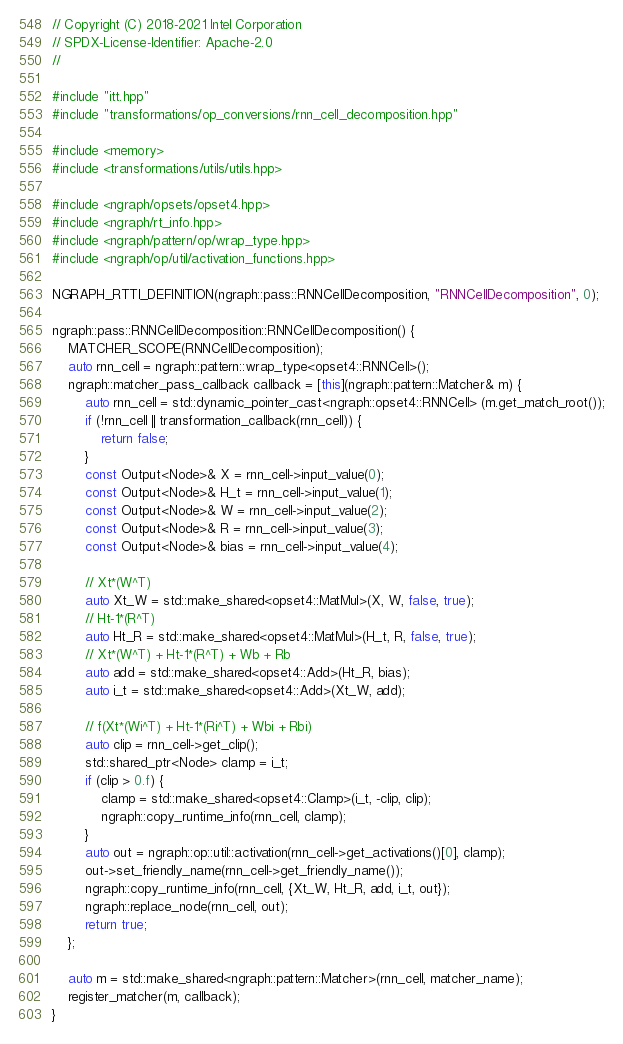<code> <loc_0><loc_0><loc_500><loc_500><_C++_>// Copyright (C) 2018-2021 Intel Corporation
// SPDX-License-Identifier: Apache-2.0
//

#include "itt.hpp"
#include "transformations/op_conversions/rnn_cell_decomposition.hpp"

#include <memory>
#include <transformations/utils/utils.hpp>

#include <ngraph/opsets/opset4.hpp>
#include <ngraph/rt_info.hpp>
#include <ngraph/pattern/op/wrap_type.hpp>
#include <ngraph/op/util/activation_functions.hpp>

NGRAPH_RTTI_DEFINITION(ngraph::pass::RNNCellDecomposition, "RNNCellDecomposition", 0);

ngraph::pass::RNNCellDecomposition::RNNCellDecomposition() {
    MATCHER_SCOPE(RNNCellDecomposition);
    auto rnn_cell = ngraph::pattern::wrap_type<opset4::RNNCell>();
    ngraph::matcher_pass_callback callback = [this](ngraph::pattern::Matcher& m) {
        auto rnn_cell = std::dynamic_pointer_cast<ngraph::opset4::RNNCell> (m.get_match_root());
        if (!rnn_cell || transformation_callback(rnn_cell)) {
            return false;
        }
        const Output<Node>& X = rnn_cell->input_value(0);
        const Output<Node>& H_t = rnn_cell->input_value(1);
        const Output<Node>& W = rnn_cell->input_value(2);
        const Output<Node>& R = rnn_cell->input_value(3);
        const Output<Node>& bias = rnn_cell->input_value(4);

        // Xt*(W^T)
        auto Xt_W = std::make_shared<opset4::MatMul>(X, W, false, true);
        // Ht-1*(R^T)
        auto Ht_R = std::make_shared<opset4::MatMul>(H_t, R, false, true);
        // Xt*(W^T) + Ht-1*(R^T) + Wb + Rb
        auto add = std::make_shared<opset4::Add>(Ht_R, bias);
        auto i_t = std::make_shared<opset4::Add>(Xt_W, add);

        // f(Xt*(Wi^T) + Ht-1*(Ri^T) + Wbi + Rbi)
        auto clip = rnn_cell->get_clip();
        std::shared_ptr<Node> clamp = i_t;
        if (clip > 0.f) {
            clamp = std::make_shared<opset4::Clamp>(i_t, -clip, clip);
            ngraph::copy_runtime_info(rnn_cell, clamp);
        }
        auto out = ngraph::op::util::activation(rnn_cell->get_activations()[0], clamp);
        out->set_friendly_name(rnn_cell->get_friendly_name());
        ngraph::copy_runtime_info(rnn_cell, {Xt_W, Ht_R, add, i_t, out});
        ngraph::replace_node(rnn_cell, out);
        return true;
    };

    auto m = std::make_shared<ngraph::pattern::Matcher>(rnn_cell, matcher_name);
    register_matcher(m, callback);
}
</code> 